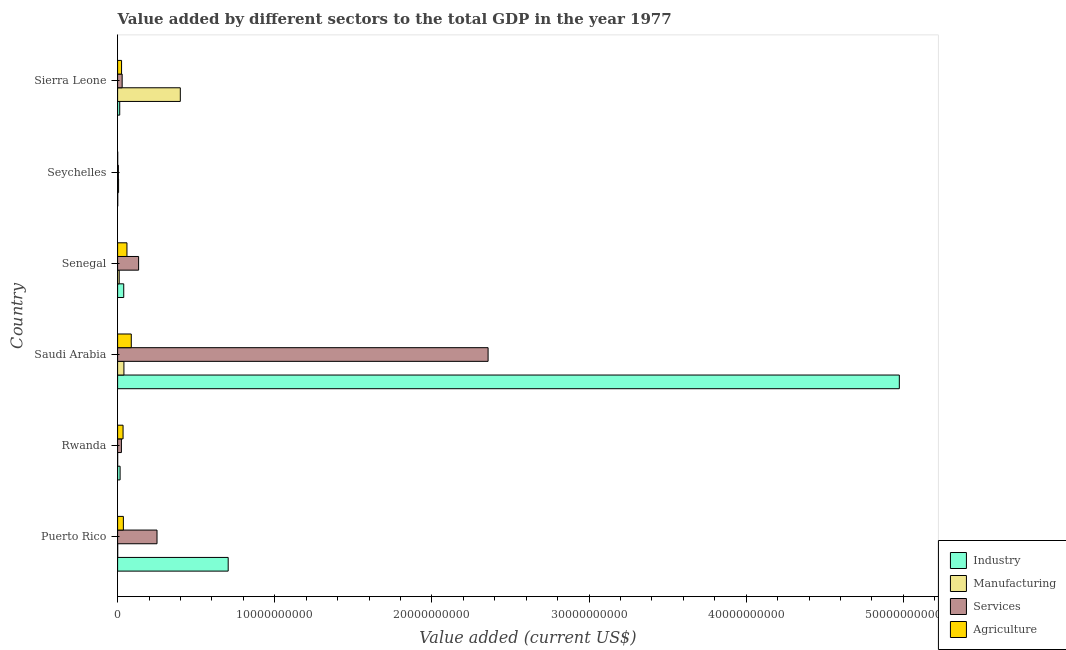How many different coloured bars are there?
Provide a short and direct response. 4. Are the number of bars per tick equal to the number of legend labels?
Provide a succinct answer. Yes. Are the number of bars on each tick of the Y-axis equal?
Offer a very short reply. Yes. How many bars are there on the 5th tick from the bottom?
Offer a very short reply. 4. What is the label of the 5th group of bars from the top?
Make the answer very short. Rwanda. In how many cases, is the number of bars for a given country not equal to the number of legend labels?
Provide a succinct answer. 0. What is the value added by services sector in Rwanda?
Your answer should be compact. 2.41e+08. Across all countries, what is the maximum value added by industrial sector?
Provide a succinct answer. 4.97e+1. Across all countries, what is the minimum value added by industrial sector?
Your answer should be compact. 8.92e+06. In which country was the value added by industrial sector maximum?
Ensure brevity in your answer.  Saudi Arabia. In which country was the value added by services sector minimum?
Your answer should be very brief. Seychelles. What is the total value added by services sector in the graph?
Make the answer very short. 2.80e+1. What is the difference between the value added by manufacturing sector in Rwanda and that in Saudi Arabia?
Offer a very short reply. -3.99e+08. What is the difference between the value added by services sector in Seychelles and the value added by industrial sector in Sierra Leone?
Your response must be concise. -8.48e+07. What is the average value added by manufacturing sector per country?
Offer a terse response. 7.60e+08. What is the difference between the value added by services sector and value added by industrial sector in Puerto Rico?
Your answer should be very brief. -4.53e+09. What is the ratio of the value added by manufacturing sector in Rwanda to that in Seychelles?
Give a very brief answer. 0.04. Is the value added by services sector in Rwanda less than that in Senegal?
Offer a terse response. Yes. Is the difference between the value added by agricultural sector in Saudi Arabia and Senegal greater than the difference between the value added by services sector in Saudi Arabia and Senegal?
Offer a terse response. No. What is the difference between the highest and the second highest value added by industrial sector?
Provide a short and direct response. 4.27e+1. What is the difference between the highest and the lowest value added by services sector?
Provide a succinct answer. 2.35e+1. Is the sum of the value added by agricultural sector in Rwanda and Senegal greater than the maximum value added by manufacturing sector across all countries?
Provide a succinct answer. No. What does the 2nd bar from the top in Seychelles represents?
Provide a short and direct response. Services. What does the 3rd bar from the bottom in Puerto Rico represents?
Your response must be concise. Services. Are all the bars in the graph horizontal?
Ensure brevity in your answer.  Yes. Are the values on the major ticks of X-axis written in scientific E-notation?
Ensure brevity in your answer.  No. How are the legend labels stacked?
Offer a very short reply. Vertical. What is the title of the graph?
Offer a terse response. Value added by different sectors to the total GDP in the year 1977. What is the label or title of the X-axis?
Make the answer very short. Value added (current US$). What is the label or title of the Y-axis?
Give a very brief answer. Country. What is the Value added (current US$) of Industry in Puerto Rico?
Offer a terse response. 7.04e+09. What is the Value added (current US$) in Manufacturing in Puerto Rico?
Provide a short and direct response. 4.63e+06. What is the Value added (current US$) of Services in Puerto Rico?
Your response must be concise. 2.51e+09. What is the Value added (current US$) in Agriculture in Puerto Rico?
Make the answer very short. 3.67e+08. What is the Value added (current US$) of Industry in Rwanda?
Provide a short and direct response. 1.58e+08. What is the Value added (current US$) of Manufacturing in Rwanda?
Ensure brevity in your answer.  2.22e+06. What is the Value added (current US$) of Services in Rwanda?
Give a very brief answer. 2.41e+08. What is the Value added (current US$) of Agriculture in Rwanda?
Offer a terse response. 3.47e+08. What is the Value added (current US$) of Industry in Saudi Arabia?
Provide a succinct answer. 4.97e+1. What is the Value added (current US$) of Manufacturing in Saudi Arabia?
Make the answer very short. 4.01e+08. What is the Value added (current US$) of Services in Saudi Arabia?
Ensure brevity in your answer.  2.36e+1. What is the Value added (current US$) of Agriculture in Saudi Arabia?
Ensure brevity in your answer.  8.70e+08. What is the Value added (current US$) of Industry in Senegal?
Make the answer very short. 3.90e+08. What is the Value added (current US$) in Manufacturing in Senegal?
Give a very brief answer. 1.01e+08. What is the Value added (current US$) in Services in Senegal?
Offer a very short reply. 1.34e+09. What is the Value added (current US$) of Agriculture in Senegal?
Keep it short and to the point. 5.95e+08. What is the Value added (current US$) of Industry in Seychelles?
Give a very brief answer. 8.92e+06. What is the Value added (current US$) in Manufacturing in Seychelles?
Your response must be concise. 6.21e+07. What is the Value added (current US$) of Services in Seychelles?
Provide a succinct answer. 4.97e+07. What is the Value added (current US$) of Agriculture in Seychelles?
Provide a succinct answer. 5.91e+06. What is the Value added (current US$) in Industry in Sierra Leone?
Keep it short and to the point. 1.34e+08. What is the Value added (current US$) in Manufacturing in Sierra Leone?
Make the answer very short. 3.99e+09. What is the Value added (current US$) of Services in Sierra Leone?
Offer a very short reply. 2.90e+08. What is the Value added (current US$) of Agriculture in Sierra Leone?
Your response must be concise. 2.52e+08. Across all countries, what is the maximum Value added (current US$) of Industry?
Give a very brief answer. 4.97e+1. Across all countries, what is the maximum Value added (current US$) of Manufacturing?
Provide a succinct answer. 3.99e+09. Across all countries, what is the maximum Value added (current US$) in Services?
Your answer should be very brief. 2.36e+1. Across all countries, what is the maximum Value added (current US$) of Agriculture?
Your answer should be very brief. 8.70e+08. Across all countries, what is the minimum Value added (current US$) of Industry?
Your response must be concise. 8.92e+06. Across all countries, what is the minimum Value added (current US$) in Manufacturing?
Make the answer very short. 2.22e+06. Across all countries, what is the minimum Value added (current US$) of Services?
Provide a short and direct response. 4.97e+07. Across all countries, what is the minimum Value added (current US$) of Agriculture?
Keep it short and to the point. 5.91e+06. What is the total Value added (current US$) of Industry in the graph?
Provide a succinct answer. 5.75e+1. What is the total Value added (current US$) in Manufacturing in the graph?
Offer a terse response. 4.56e+09. What is the total Value added (current US$) of Services in the graph?
Keep it short and to the point. 2.80e+1. What is the total Value added (current US$) of Agriculture in the graph?
Your answer should be compact. 2.44e+09. What is the difference between the Value added (current US$) of Industry in Puerto Rico and that in Rwanda?
Ensure brevity in your answer.  6.88e+09. What is the difference between the Value added (current US$) in Manufacturing in Puerto Rico and that in Rwanda?
Your response must be concise. 2.41e+06. What is the difference between the Value added (current US$) in Services in Puerto Rico and that in Rwanda?
Make the answer very short. 2.27e+09. What is the difference between the Value added (current US$) in Agriculture in Puerto Rico and that in Rwanda?
Your response must be concise. 2.01e+07. What is the difference between the Value added (current US$) of Industry in Puerto Rico and that in Saudi Arabia?
Ensure brevity in your answer.  -4.27e+1. What is the difference between the Value added (current US$) of Manufacturing in Puerto Rico and that in Saudi Arabia?
Make the answer very short. -3.97e+08. What is the difference between the Value added (current US$) in Services in Puerto Rico and that in Saudi Arabia?
Give a very brief answer. -2.11e+1. What is the difference between the Value added (current US$) of Agriculture in Puerto Rico and that in Saudi Arabia?
Make the answer very short. -5.03e+08. What is the difference between the Value added (current US$) in Industry in Puerto Rico and that in Senegal?
Offer a very short reply. 6.65e+09. What is the difference between the Value added (current US$) of Manufacturing in Puerto Rico and that in Senegal?
Provide a succinct answer. -9.68e+07. What is the difference between the Value added (current US$) in Services in Puerto Rico and that in Senegal?
Make the answer very short. 1.17e+09. What is the difference between the Value added (current US$) of Agriculture in Puerto Rico and that in Senegal?
Provide a succinct answer. -2.28e+08. What is the difference between the Value added (current US$) of Industry in Puerto Rico and that in Seychelles?
Provide a succinct answer. 7.03e+09. What is the difference between the Value added (current US$) in Manufacturing in Puerto Rico and that in Seychelles?
Your answer should be very brief. -5.75e+07. What is the difference between the Value added (current US$) of Services in Puerto Rico and that in Seychelles?
Provide a short and direct response. 2.46e+09. What is the difference between the Value added (current US$) of Agriculture in Puerto Rico and that in Seychelles?
Make the answer very short. 3.61e+08. What is the difference between the Value added (current US$) of Industry in Puerto Rico and that in Sierra Leone?
Offer a very short reply. 6.90e+09. What is the difference between the Value added (current US$) in Manufacturing in Puerto Rico and that in Sierra Leone?
Provide a succinct answer. -3.99e+09. What is the difference between the Value added (current US$) in Services in Puerto Rico and that in Sierra Leone?
Your response must be concise. 2.22e+09. What is the difference between the Value added (current US$) of Agriculture in Puerto Rico and that in Sierra Leone?
Your answer should be very brief. 1.15e+08. What is the difference between the Value added (current US$) of Industry in Rwanda and that in Saudi Arabia?
Your response must be concise. -4.96e+1. What is the difference between the Value added (current US$) in Manufacturing in Rwanda and that in Saudi Arabia?
Offer a terse response. -3.99e+08. What is the difference between the Value added (current US$) of Services in Rwanda and that in Saudi Arabia?
Ensure brevity in your answer.  -2.33e+1. What is the difference between the Value added (current US$) in Agriculture in Rwanda and that in Saudi Arabia?
Your answer should be very brief. -5.23e+08. What is the difference between the Value added (current US$) in Industry in Rwanda and that in Senegal?
Provide a succinct answer. -2.31e+08. What is the difference between the Value added (current US$) in Manufacturing in Rwanda and that in Senegal?
Keep it short and to the point. -9.92e+07. What is the difference between the Value added (current US$) in Services in Rwanda and that in Senegal?
Ensure brevity in your answer.  -1.09e+09. What is the difference between the Value added (current US$) of Agriculture in Rwanda and that in Senegal?
Your answer should be very brief. -2.48e+08. What is the difference between the Value added (current US$) of Industry in Rwanda and that in Seychelles?
Ensure brevity in your answer.  1.49e+08. What is the difference between the Value added (current US$) in Manufacturing in Rwanda and that in Seychelles?
Your response must be concise. -5.99e+07. What is the difference between the Value added (current US$) in Services in Rwanda and that in Seychelles?
Give a very brief answer. 1.92e+08. What is the difference between the Value added (current US$) of Agriculture in Rwanda and that in Seychelles?
Make the answer very short. 3.41e+08. What is the difference between the Value added (current US$) in Industry in Rwanda and that in Sierra Leone?
Your response must be concise. 2.38e+07. What is the difference between the Value added (current US$) in Manufacturing in Rwanda and that in Sierra Leone?
Make the answer very short. -3.99e+09. What is the difference between the Value added (current US$) in Services in Rwanda and that in Sierra Leone?
Your answer should be very brief. -4.84e+07. What is the difference between the Value added (current US$) in Agriculture in Rwanda and that in Sierra Leone?
Provide a succinct answer. 9.52e+07. What is the difference between the Value added (current US$) of Industry in Saudi Arabia and that in Senegal?
Give a very brief answer. 4.94e+1. What is the difference between the Value added (current US$) of Manufacturing in Saudi Arabia and that in Senegal?
Offer a very short reply. 3.00e+08. What is the difference between the Value added (current US$) in Services in Saudi Arabia and that in Senegal?
Your response must be concise. 2.22e+1. What is the difference between the Value added (current US$) of Agriculture in Saudi Arabia and that in Senegal?
Keep it short and to the point. 2.75e+08. What is the difference between the Value added (current US$) of Industry in Saudi Arabia and that in Seychelles?
Provide a succinct answer. 4.97e+1. What is the difference between the Value added (current US$) in Manufacturing in Saudi Arabia and that in Seychelles?
Offer a very short reply. 3.39e+08. What is the difference between the Value added (current US$) in Services in Saudi Arabia and that in Seychelles?
Offer a terse response. 2.35e+1. What is the difference between the Value added (current US$) of Agriculture in Saudi Arabia and that in Seychelles?
Offer a very short reply. 8.64e+08. What is the difference between the Value added (current US$) in Industry in Saudi Arabia and that in Sierra Leone?
Offer a very short reply. 4.96e+1. What is the difference between the Value added (current US$) in Manufacturing in Saudi Arabia and that in Sierra Leone?
Your answer should be very brief. -3.59e+09. What is the difference between the Value added (current US$) in Services in Saudi Arabia and that in Sierra Leone?
Offer a terse response. 2.33e+1. What is the difference between the Value added (current US$) in Agriculture in Saudi Arabia and that in Sierra Leone?
Offer a very short reply. 6.18e+08. What is the difference between the Value added (current US$) of Industry in Senegal and that in Seychelles?
Keep it short and to the point. 3.81e+08. What is the difference between the Value added (current US$) in Manufacturing in Senegal and that in Seychelles?
Make the answer very short. 3.94e+07. What is the difference between the Value added (current US$) in Services in Senegal and that in Seychelles?
Offer a very short reply. 1.29e+09. What is the difference between the Value added (current US$) of Agriculture in Senegal and that in Seychelles?
Offer a very short reply. 5.89e+08. What is the difference between the Value added (current US$) of Industry in Senegal and that in Sierra Leone?
Provide a succinct answer. 2.55e+08. What is the difference between the Value added (current US$) of Manufacturing in Senegal and that in Sierra Leone?
Keep it short and to the point. -3.89e+09. What is the difference between the Value added (current US$) of Services in Senegal and that in Sierra Leone?
Give a very brief answer. 1.05e+09. What is the difference between the Value added (current US$) in Agriculture in Senegal and that in Sierra Leone?
Provide a succinct answer. 3.43e+08. What is the difference between the Value added (current US$) of Industry in Seychelles and that in Sierra Leone?
Your response must be concise. -1.26e+08. What is the difference between the Value added (current US$) in Manufacturing in Seychelles and that in Sierra Leone?
Your response must be concise. -3.93e+09. What is the difference between the Value added (current US$) in Services in Seychelles and that in Sierra Leone?
Make the answer very short. -2.40e+08. What is the difference between the Value added (current US$) in Agriculture in Seychelles and that in Sierra Leone?
Your answer should be compact. -2.46e+08. What is the difference between the Value added (current US$) of Industry in Puerto Rico and the Value added (current US$) of Manufacturing in Rwanda?
Provide a succinct answer. 7.03e+09. What is the difference between the Value added (current US$) of Industry in Puerto Rico and the Value added (current US$) of Services in Rwanda?
Make the answer very short. 6.80e+09. What is the difference between the Value added (current US$) in Industry in Puerto Rico and the Value added (current US$) in Agriculture in Rwanda?
Provide a short and direct response. 6.69e+09. What is the difference between the Value added (current US$) of Manufacturing in Puerto Rico and the Value added (current US$) of Services in Rwanda?
Your answer should be compact. -2.37e+08. What is the difference between the Value added (current US$) in Manufacturing in Puerto Rico and the Value added (current US$) in Agriculture in Rwanda?
Ensure brevity in your answer.  -3.42e+08. What is the difference between the Value added (current US$) of Services in Puerto Rico and the Value added (current US$) of Agriculture in Rwanda?
Offer a terse response. 2.16e+09. What is the difference between the Value added (current US$) of Industry in Puerto Rico and the Value added (current US$) of Manufacturing in Saudi Arabia?
Your response must be concise. 6.64e+09. What is the difference between the Value added (current US$) in Industry in Puerto Rico and the Value added (current US$) in Services in Saudi Arabia?
Provide a succinct answer. -1.65e+1. What is the difference between the Value added (current US$) in Industry in Puerto Rico and the Value added (current US$) in Agriculture in Saudi Arabia?
Your answer should be very brief. 6.17e+09. What is the difference between the Value added (current US$) in Manufacturing in Puerto Rico and the Value added (current US$) in Services in Saudi Arabia?
Offer a very short reply. -2.36e+1. What is the difference between the Value added (current US$) of Manufacturing in Puerto Rico and the Value added (current US$) of Agriculture in Saudi Arabia?
Give a very brief answer. -8.65e+08. What is the difference between the Value added (current US$) of Services in Puerto Rico and the Value added (current US$) of Agriculture in Saudi Arabia?
Your answer should be very brief. 1.64e+09. What is the difference between the Value added (current US$) of Industry in Puerto Rico and the Value added (current US$) of Manufacturing in Senegal?
Provide a short and direct response. 6.94e+09. What is the difference between the Value added (current US$) of Industry in Puerto Rico and the Value added (current US$) of Services in Senegal?
Keep it short and to the point. 5.70e+09. What is the difference between the Value added (current US$) in Industry in Puerto Rico and the Value added (current US$) in Agriculture in Senegal?
Provide a short and direct response. 6.44e+09. What is the difference between the Value added (current US$) in Manufacturing in Puerto Rico and the Value added (current US$) in Services in Senegal?
Ensure brevity in your answer.  -1.33e+09. What is the difference between the Value added (current US$) in Manufacturing in Puerto Rico and the Value added (current US$) in Agriculture in Senegal?
Offer a terse response. -5.90e+08. What is the difference between the Value added (current US$) in Services in Puerto Rico and the Value added (current US$) in Agriculture in Senegal?
Offer a very short reply. 1.91e+09. What is the difference between the Value added (current US$) in Industry in Puerto Rico and the Value added (current US$) in Manufacturing in Seychelles?
Your answer should be compact. 6.97e+09. What is the difference between the Value added (current US$) in Industry in Puerto Rico and the Value added (current US$) in Services in Seychelles?
Keep it short and to the point. 6.99e+09. What is the difference between the Value added (current US$) in Industry in Puerto Rico and the Value added (current US$) in Agriculture in Seychelles?
Give a very brief answer. 7.03e+09. What is the difference between the Value added (current US$) in Manufacturing in Puerto Rico and the Value added (current US$) in Services in Seychelles?
Your answer should be compact. -4.51e+07. What is the difference between the Value added (current US$) in Manufacturing in Puerto Rico and the Value added (current US$) in Agriculture in Seychelles?
Provide a short and direct response. -1.28e+06. What is the difference between the Value added (current US$) of Services in Puerto Rico and the Value added (current US$) of Agriculture in Seychelles?
Make the answer very short. 2.50e+09. What is the difference between the Value added (current US$) of Industry in Puerto Rico and the Value added (current US$) of Manufacturing in Sierra Leone?
Your answer should be compact. 3.05e+09. What is the difference between the Value added (current US$) in Industry in Puerto Rico and the Value added (current US$) in Services in Sierra Leone?
Give a very brief answer. 6.75e+09. What is the difference between the Value added (current US$) of Industry in Puerto Rico and the Value added (current US$) of Agriculture in Sierra Leone?
Give a very brief answer. 6.79e+09. What is the difference between the Value added (current US$) of Manufacturing in Puerto Rico and the Value added (current US$) of Services in Sierra Leone?
Your answer should be very brief. -2.85e+08. What is the difference between the Value added (current US$) of Manufacturing in Puerto Rico and the Value added (current US$) of Agriculture in Sierra Leone?
Make the answer very short. -2.47e+08. What is the difference between the Value added (current US$) of Services in Puerto Rico and the Value added (current US$) of Agriculture in Sierra Leone?
Offer a terse response. 2.26e+09. What is the difference between the Value added (current US$) in Industry in Rwanda and the Value added (current US$) in Manufacturing in Saudi Arabia?
Make the answer very short. -2.43e+08. What is the difference between the Value added (current US$) in Industry in Rwanda and the Value added (current US$) in Services in Saudi Arabia?
Provide a succinct answer. -2.34e+1. What is the difference between the Value added (current US$) in Industry in Rwanda and the Value added (current US$) in Agriculture in Saudi Arabia?
Your answer should be compact. -7.11e+08. What is the difference between the Value added (current US$) in Manufacturing in Rwanda and the Value added (current US$) in Services in Saudi Arabia?
Give a very brief answer. -2.36e+1. What is the difference between the Value added (current US$) in Manufacturing in Rwanda and the Value added (current US$) in Agriculture in Saudi Arabia?
Provide a succinct answer. -8.68e+08. What is the difference between the Value added (current US$) of Services in Rwanda and the Value added (current US$) of Agriculture in Saudi Arabia?
Your answer should be compact. -6.28e+08. What is the difference between the Value added (current US$) of Industry in Rwanda and the Value added (current US$) of Manufacturing in Senegal?
Offer a very short reply. 5.69e+07. What is the difference between the Value added (current US$) of Industry in Rwanda and the Value added (current US$) of Services in Senegal?
Give a very brief answer. -1.18e+09. What is the difference between the Value added (current US$) of Industry in Rwanda and the Value added (current US$) of Agriculture in Senegal?
Provide a short and direct response. -4.37e+08. What is the difference between the Value added (current US$) in Manufacturing in Rwanda and the Value added (current US$) in Services in Senegal?
Your answer should be very brief. -1.33e+09. What is the difference between the Value added (current US$) in Manufacturing in Rwanda and the Value added (current US$) in Agriculture in Senegal?
Your response must be concise. -5.93e+08. What is the difference between the Value added (current US$) in Services in Rwanda and the Value added (current US$) in Agriculture in Senegal?
Ensure brevity in your answer.  -3.54e+08. What is the difference between the Value added (current US$) of Industry in Rwanda and the Value added (current US$) of Manufacturing in Seychelles?
Keep it short and to the point. 9.62e+07. What is the difference between the Value added (current US$) in Industry in Rwanda and the Value added (current US$) in Services in Seychelles?
Your response must be concise. 1.09e+08. What is the difference between the Value added (current US$) of Industry in Rwanda and the Value added (current US$) of Agriculture in Seychelles?
Ensure brevity in your answer.  1.52e+08. What is the difference between the Value added (current US$) in Manufacturing in Rwanda and the Value added (current US$) in Services in Seychelles?
Offer a very short reply. -4.75e+07. What is the difference between the Value added (current US$) of Manufacturing in Rwanda and the Value added (current US$) of Agriculture in Seychelles?
Your answer should be compact. -3.69e+06. What is the difference between the Value added (current US$) in Services in Rwanda and the Value added (current US$) in Agriculture in Seychelles?
Keep it short and to the point. 2.35e+08. What is the difference between the Value added (current US$) in Industry in Rwanda and the Value added (current US$) in Manufacturing in Sierra Leone?
Keep it short and to the point. -3.83e+09. What is the difference between the Value added (current US$) in Industry in Rwanda and the Value added (current US$) in Services in Sierra Leone?
Your answer should be compact. -1.31e+08. What is the difference between the Value added (current US$) of Industry in Rwanda and the Value added (current US$) of Agriculture in Sierra Leone?
Give a very brief answer. -9.33e+07. What is the difference between the Value added (current US$) of Manufacturing in Rwanda and the Value added (current US$) of Services in Sierra Leone?
Provide a short and direct response. -2.88e+08. What is the difference between the Value added (current US$) in Manufacturing in Rwanda and the Value added (current US$) in Agriculture in Sierra Leone?
Offer a very short reply. -2.49e+08. What is the difference between the Value added (current US$) in Services in Rwanda and the Value added (current US$) in Agriculture in Sierra Leone?
Keep it short and to the point. -1.03e+07. What is the difference between the Value added (current US$) of Industry in Saudi Arabia and the Value added (current US$) of Manufacturing in Senegal?
Provide a short and direct response. 4.96e+1. What is the difference between the Value added (current US$) of Industry in Saudi Arabia and the Value added (current US$) of Services in Senegal?
Provide a succinct answer. 4.84e+1. What is the difference between the Value added (current US$) of Industry in Saudi Arabia and the Value added (current US$) of Agriculture in Senegal?
Your response must be concise. 4.91e+1. What is the difference between the Value added (current US$) in Manufacturing in Saudi Arabia and the Value added (current US$) in Services in Senegal?
Provide a short and direct response. -9.35e+08. What is the difference between the Value added (current US$) in Manufacturing in Saudi Arabia and the Value added (current US$) in Agriculture in Senegal?
Keep it short and to the point. -1.93e+08. What is the difference between the Value added (current US$) in Services in Saudi Arabia and the Value added (current US$) in Agriculture in Senegal?
Your response must be concise. 2.30e+1. What is the difference between the Value added (current US$) of Industry in Saudi Arabia and the Value added (current US$) of Manufacturing in Seychelles?
Ensure brevity in your answer.  4.97e+1. What is the difference between the Value added (current US$) of Industry in Saudi Arabia and the Value added (current US$) of Services in Seychelles?
Provide a short and direct response. 4.97e+1. What is the difference between the Value added (current US$) in Industry in Saudi Arabia and the Value added (current US$) in Agriculture in Seychelles?
Your response must be concise. 4.97e+1. What is the difference between the Value added (current US$) in Manufacturing in Saudi Arabia and the Value added (current US$) in Services in Seychelles?
Your answer should be very brief. 3.52e+08. What is the difference between the Value added (current US$) in Manufacturing in Saudi Arabia and the Value added (current US$) in Agriculture in Seychelles?
Offer a terse response. 3.96e+08. What is the difference between the Value added (current US$) in Services in Saudi Arabia and the Value added (current US$) in Agriculture in Seychelles?
Provide a short and direct response. 2.36e+1. What is the difference between the Value added (current US$) in Industry in Saudi Arabia and the Value added (current US$) in Manufacturing in Sierra Leone?
Give a very brief answer. 4.58e+1. What is the difference between the Value added (current US$) in Industry in Saudi Arabia and the Value added (current US$) in Services in Sierra Leone?
Ensure brevity in your answer.  4.95e+1. What is the difference between the Value added (current US$) of Industry in Saudi Arabia and the Value added (current US$) of Agriculture in Sierra Leone?
Ensure brevity in your answer.  4.95e+1. What is the difference between the Value added (current US$) in Manufacturing in Saudi Arabia and the Value added (current US$) in Services in Sierra Leone?
Your answer should be compact. 1.12e+08. What is the difference between the Value added (current US$) in Manufacturing in Saudi Arabia and the Value added (current US$) in Agriculture in Sierra Leone?
Your answer should be compact. 1.50e+08. What is the difference between the Value added (current US$) in Services in Saudi Arabia and the Value added (current US$) in Agriculture in Sierra Leone?
Give a very brief answer. 2.33e+1. What is the difference between the Value added (current US$) in Industry in Senegal and the Value added (current US$) in Manufacturing in Seychelles?
Your answer should be compact. 3.28e+08. What is the difference between the Value added (current US$) in Industry in Senegal and the Value added (current US$) in Services in Seychelles?
Make the answer very short. 3.40e+08. What is the difference between the Value added (current US$) of Industry in Senegal and the Value added (current US$) of Agriculture in Seychelles?
Provide a short and direct response. 3.84e+08. What is the difference between the Value added (current US$) in Manufacturing in Senegal and the Value added (current US$) in Services in Seychelles?
Offer a very short reply. 5.18e+07. What is the difference between the Value added (current US$) of Manufacturing in Senegal and the Value added (current US$) of Agriculture in Seychelles?
Your answer should be very brief. 9.55e+07. What is the difference between the Value added (current US$) of Services in Senegal and the Value added (current US$) of Agriculture in Seychelles?
Your response must be concise. 1.33e+09. What is the difference between the Value added (current US$) of Industry in Senegal and the Value added (current US$) of Manufacturing in Sierra Leone?
Your answer should be very brief. -3.60e+09. What is the difference between the Value added (current US$) of Industry in Senegal and the Value added (current US$) of Services in Sierra Leone?
Ensure brevity in your answer.  9.99e+07. What is the difference between the Value added (current US$) in Industry in Senegal and the Value added (current US$) in Agriculture in Sierra Leone?
Make the answer very short. 1.38e+08. What is the difference between the Value added (current US$) in Manufacturing in Senegal and the Value added (current US$) in Services in Sierra Leone?
Make the answer very short. -1.88e+08. What is the difference between the Value added (current US$) of Manufacturing in Senegal and the Value added (current US$) of Agriculture in Sierra Leone?
Your response must be concise. -1.50e+08. What is the difference between the Value added (current US$) of Services in Senegal and the Value added (current US$) of Agriculture in Sierra Leone?
Ensure brevity in your answer.  1.08e+09. What is the difference between the Value added (current US$) in Industry in Seychelles and the Value added (current US$) in Manufacturing in Sierra Leone?
Offer a very short reply. -3.98e+09. What is the difference between the Value added (current US$) of Industry in Seychelles and the Value added (current US$) of Services in Sierra Leone?
Ensure brevity in your answer.  -2.81e+08. What is the difference between the Value added (current US$) of Industry in Seychelles and the Value added (current US$) of Agriculture in Sierra Leone?
Your response must be concise. -2.43e+08. What is the difference between the Value added (current US$) in Manufacturing in Seychelles and the Value added (current US$) in Services in Sierra Leone?
Offer a very short reply. -2.28e+08. What is the difference between the Value added (current US$) in Manufacturing in Seychelles and the Value added (current US$) in Agriculture in Sierra Leone?
Your answer should be very brief. -1.90e+08. What is the difference between the Value added (current US$) in Services in Seychelles and the Value added (current US$) in Agriculture in Sierra Leone?
Your answer should be very brief. -2.02e+08. What is the average Value added (current US$) in Industry per country?
Provide a succinct answer. 9.58e+09. What is the average Value added (current US$) in Manufacturing per country?
Make the answer very short. 7.60e+08. What is the average Value added (current US$) in Services per country?
Your response must be concise. 4.67e+09. What is the average Value added (current US$) of Agriculture per country?
Your answer should be very brief. 4.06e+08. What is the difference between the Value added (current US$) in Industry and Value added (current US$) in Manufacturing in Puerto Rico?
Your answer should be very brief. 7.03e+09. What is the difference between the Value added (current US$) in Industry and Value added (current US$) in Services in Puerto Rico?
Ensure brevity in your answer.  4.53e+09. What is the difference between the Value added (current US$) in Industry and Value added (current US$) in Agriculture in Puerto Rico?
Provide a short and direct response. 6.67e+09. What is the difference between the Value added (current US$) of Manufacturing and Value added (current US$) of Services in Puerto Rico?
Keep it short and to the point. -2.50e+09. What is the difference between the Value added (current US$) of Manufacturing and Value added (current US$) of Agriculture in Puerto Rico?
Ensure brevity in your answer.  -3.62e+08. What is the difference between the Value added (current US$) of Services and Value added (current US$) of Agriculture in Puerto Rico?
Your answer should be compact. 2.14e+09. What is the difference between the Value added (current US$) in Industry and Value added (current US$) in Manufacturing in Rwanda?
Keep it short and to the point. 1.56e+08. What is the difference between the Value added (current US$) in Industry and Value added (current US$) in Services in Rwanda?
Offer a terse response. -8.31e+07. What is the difference between the Value added (current US$) of Industry and Value added (current US$) of Agriculture in Rwanda?
Ensure brevity in your answer.  -1.89e+08. What is the difference between the Value added (current US$) of Manufacturing and Value added (current US$) of Services in Rwanda?
Keep it short and to the point. -2.39e+08. What is the difference between the Value added (current US$) in Manufacturing and Value added (current US$) in Agriculture in Rwanda?
Offer a terse response. -3.45e+08. What is the difference between the Value added (current US$) of Services and Value added (current US$) of Agriculture in Rwanda?
Provide a short and direct response. -1.05e+08. What is the difference between the Value added (current US$) in Industry and Value added (current US$) in Manufacturing in Saudi Arabia?
Your answer should be very brief. 4.93e+1. What is the difference between the Value added (current US$) of Industry and Value added (current US$) of Services in Saudi Arabia?
Your answer should be very brief. 2.62e+1. What is the difference between the Value added (current US$) in Industry and Value added (current US$) in Agriculture in Saudi Arabia?
Provide a succinct answer. 4.89e+1. What is the difference between the Value added (current US$) in Manufacturing and Value added (current US$) in Services in Saudi Arabia?
Provide a succinct answer. -2.32e+1. What is the difference between the Value added (current US$) of Manufacturing and Value added (current US$) of Agriculture in Saudi Arabia?
Offer a very short reply. -4.68e+08. What is the difference between the Value added (current US$) in Services and Value added (current US$) in Agriculture in Saudi Arabia?
Give a very brief answer. 2.27e+1. What is the difference between the Value added (current US$) of Industry and Value added (current US$) of Manufacturing in Senegal?
Offer a terse response. 2.88e+08. What is the difference between the Value added (current US$) in Industry and Value added (current US$) in Services in Senegal?
Offer a very short reply. -9.46e+08. What is the difference between the Value added (current US$) of Industry and Value added (current US$) of Agriculture in Senegal?
Make the answer very short. -2.05e+08. What is the difference between the Value added (current US$) in Manufacturing and Value added (current US$) in Services in Senegal?
Your response must be concise. -1.23e+09. What is the difference between the Value added (current US$) in Manufacturing and Value added (current US$) in Agriculture in Senegal?
Your answer should be very brief. -4.94e+08. What is the difference between the Value added (current US$) in Services and Value added (current US$) in Agriculture in Senegal?
Your answer should be very brief. 7.41e+08. What is the difference between the Value added (current US$) of Industry and Value added (current US$) of Manufacturing in Seychelles?
Make the answer very short. -5.32e+07. What is the difference between the Value added (current US$) of Industry and Value added (current US$) of Services in Seychelles?
Your answer should be very brief. -4.08e+07. What is the difference between the Value added (current US$) in Industry and Value added (current US$) in Agriculture in Seychelles?
Offer a very short reply. 3.01e+06. What is the difference between the Value added (current US$) in Manufacturing and Value added (current US$) in Services in Seychelles?
Offer a terse response. 1.24e+07. What is the difference between the Value added (current US$) in Manufacturing and Value added (current US$) in Agriculture in Seychelles?
Provide a succinct answer. 5.62e+07. What is the difference between the Value added (current US$) of Services and Value added (current US$) of Agriculture in Seychelles?
Your answer should be compact. 4.38e+07. What is the difference between the Value added (current US$) of Industry and Value added (current US$) of Manufacturing in Sierra Leone?
Ensure brevity in your answer.  -3.86e+09. What is the difference between the Value added (current US$) in Industry and Value added (current US$) in Services in Sierra Leone?
Keep it short and to the point. -1.55e+08. What is the difference between the Value added (current US$) of Industry and Value added (current US$) of Agriculture in Sierra Leone?
Your answer should be compact. -1.17e+08. What is the difference between the Value added (current US$) in Manufacturing and Value added (current US$) in Services in Sierra Leone?
Provide a short and direct response. 3.70e+09. What is the difference between the Value added (current US$) of Manufacturing and Value added (current US$) of Agriculture in Sierra Leone?
Ensure brevity in your answer.  3.74e+09. What is the difference between the Value added (current US$) of Services and Value added (current US$) of Agriculture in Sierra Leone?
Your response must be concise. 3.81e+07. What is the ratio of the Value added (current US$) of Industry in Puerto Rico to that in Rwanda?
Offer a terse response. 44.44. What is the ratio of the Value added (current US$) of Manufacturing in Puerto Rico to that in Rwanda?
Your answer should be very brief. 2.08. What is the ratio of the Value added (current US$) in Services in Puerto Rico to that in Rwanda?
Your answer should be very brief. 10.39. What is the ratio of the Value added (current US$) in Agriculture in Puerto Rico to that in Rwanda?
Offer a terse response. 1.06. What is the ratio of the Value added (current US$) in Industry in Puerto Rico to that in Saudi Arabia?
Provide a short and direct response. 0.14. What is the ratio of the Value added (current US$) in Manufacturing in Puerto Rico to that in Saudi Arabia?
Your response must be concise. 0.01. What is the ratio of the Value added (current US$) of Services in Puerto Rico to that in Saudi Arabia?
Offer a terse response. 0.11. What is the ratio of the Value added (current US$) of Agriculture in Puerto Rico to that in Saudi Arabia?
Keep it short and to the point. 0.42. What is the ratio of the Value added (current US$) of Industry in Puerto Rico to that in Senegal?
Give a very brief answer. 18.06. What is the ratio of the Value added (current US$) of Manufacturing in Puerto Rico to that in Senegal?
Offer a terse response. 0.05. What is the ratio of the Value added (current US$) of Services in Puerto Rico to that in Senegal?
Provide a succinct answer. 1.88. What is the ratio of the Value added (current US$) in Agriculture in Puerto Rico to that in Senegal?
Offer a very short reply. 0.62. What is the ratio of the Value added (current US$) in Industry in Puerto Rico to that in Seychelles?
Offer a very short reply. 788.64. What is the ratio of the Value added (current US$) of Manufacturing in Puerto Rico to that in Seychelles?
Keep it short and to the point. 0.07. What is the ratio of the Value added (current US$) of Services in Puerto Rico to that in Seychelles?
Make the answer very short. 50.46. What is the ratio of the Value added (current US$) in Agriculture in Puerto Rico to that in Seychelles?
Offer a very short reply. 62.05. What is the ratio of the Value added (current US$) in Industry in Puerto Rico to that in Sierra Leone?
Provide a succinct answer. 52.32. What is the ratio of the Value added (current US$) in Manufacturing in Puerto Rico to that in Sierra Leone?
Offer a very short reply. 0. What is the ratio of the Value added (current US$) in Services in Puerto Rico to that in Sierra Leone?
Keep it short and to the point. 8.65. What is the ratio of the Value added (current US$) of Agriculture in Puerto Rico to that in Sierra Leone?
Your answer should be compact. 1.46. What is the ratio of the Value added (current US$) of Industry in Rwanda to that in Saudi Arabia?
Your answer should be very brief. 0. What is the ratio of the Value added (current US$) in Manufacturing in Rwanda to that in Saudi Arabia?
Keep it short and to the point. 0.01. What is the ratio of the Value added (current US$) of Services in Rwanda to that in Saudi Arabia?
Your answer should be very brief. 0.01. What is the ratio of the Value added (current US$) in Agriculture in Rwanda to that in Saudi Arabia?
Your answer should be compact. 0.4. What is the ratio of the Value added (current US$) in Industry in Rwanda to that in Senegal?
Give a very brief answer. 0.41. What is the ratio of the Value added (current US$) of Manufacturing in Rwanda to that in Senegal?
Ensure brevity in your answer.  0.02. What is the ratio of the Value added (current US$) of Services in Rwanda to that in Senegal?
Your answer should be very brief. 0.18. What is the ratio of the Value added (current US$) of Agriculture in Rwanda to that in Senegal?
Offer a terse response. 0.58. What is the ratio of the Value added (current US$) in Industry in Rwanda to that in Seychelles?
Your answer should be very brief. 17.75. What is the ratio of the Value added (current US$) in Manufacturing in Rwanda to that in Seychelles?
Provide a short and direct response. 0.04. What is the ratio of the Value added (current US$) of Services in Rwanda to that in Seychelles?
Offer a terse response. 4.86. What is the ratio of the Value added (current US$) in Agriculture in Rwanda to that in Seychelles?
Offer a very short reply. 58.66. What is the ratio of the Value added (current US$) in Industry in Rwanda to that in Sierra Leone?
Provide a succinct answer. 1.18. What is the ratio of the Value added (current US$) in Manufacturing in Rwanda to that in Sierra Leone?
Your answer should be compact. 0. What is the ratio of the Value added (current US$) of Services in Rwanda to that in Sierra Leone?
Offer a very short reply. 0.83. What is the ratio of the Value added (current US$) in Agriculture in Rwanda to that in Sierra Leone?
Your answer should be compact. 1.38. What is the ratio of the Value added (current US$) in Industry in Saudi Arabia to that in Senegal?
Provide a succinct answer. 127.65. What is the ratio of the Value added (current US$) of Manufacturing in Saudi Arabia to that in Senegal?
Give a very brief answer. 3.96. What is the ratio of the Value added (current US$) of Services in Saudi Arabia to that in Senegal?
Your answer should be very brief. 17.64. What is the ratio of the Value added (current US$) of Agriculture in Saudi Arabia to that in Senegal?
Keep it short and to the point. 1.46. What is the ratio of the Value added (current US$) in Industry in Saudi Arabia to that in Seychelles?
Your response must be concise. 5574.85. What is the ratio of the Value added (current US$) in Manufacturing in Saudi Arabia to that in Seychelles?
Keep it short and to the point. 6.47. What is the ratio of the Value added (current US$) in Services in Saudi Arabia to that in Seychelles?
Provide a succinct answer. 474.45. What is the ratio of the Value added (current US$) in Agriculture in Saudi Arabia to that in Seychelles?
Offer a terse response. 147.08. What is the ratio of the Value added (current US$) of Industry in Saudi Arabia to that in Sierra Leone?
Your response must be concise. 369.85. What is the ratio of the Value added (current US$) of Manufacturing in Saudi Arabia to that in Sierra Leone?
Ensure brevity in your answer.  0.1. What is the ratio of the Value added (current US$) in Services in Saudi Arabia to that in Sierra Leone?
Ensure brevity in your answer.  81.35. What is the ratio of the Value added (current US$) of Agriculture in Saudi Arabia to that in Sierra Leone?
Your response must be concise. 3.46. What is the ratio of the Value added (current US$) of Industry in Senegal to that in Seychelles?
Give a very brief answer. 43.67. What is the ratio of the Value added (current US$) in Manufacturing in Senegal to that in Seychelles?
Provide a succinct answer. 1.63. What is the ratio of the Value added (current US$) in Services in Senegal to that in Seychelles?
Offer a very short reply. 26.89. What is the ratio of the Value added (current US$) in Agriculture in Senegal to that in Seychelles?
Provide a short and direct response. 100.61. What is the ratio of the Value added (current US$) in Industry in Senegal to that in Sierra Leone?
Make the answer very short. 2.9. What is the ratio of the Value added (current US$) of Manufacturing in Senegal to that in Sierra Leone?
Provide a short and direct response. 0.03. What is the ratio of the Value added (current US$) in Services in Senegal to that in Sierra Leone?
Your answer should be compact. 4.61. What is the ratio of the Value added (current US$) in Agriculture in Senegal to that in Sierra Leone?
Provide a succinct answer. 2.36. What is the ratio of the Value added (current US$) of Industry in Seychelles to that in Sierra Leone?
Give a very brief answer. 0.07. What is the ratio of the Value added (current US$) of Manufacturing in Seychelles to that in Sierra Leone?
Offer a terse response. 0.02. What is the ratio of the Value added (current US$) in Services in Seychelles to that in Sierra Leone?
Keep it short and to the point. 0.17. What is the ratio of the Value added (current US$) of Agriculture in Seychelles to that in Sierra Leone?
Ensure brevity in your answer.  0.02. What is the difference between the highest and the second highest Value added (current US$) of Industry?
Offer a terse response. 4.27e+1. What is the difference between the highest and the second highest Value added (current US$) in Manufacturing?
Your response must be concise. 3.59e+09. What is the difference between the highest and the second highest Value added (current US$) of Services?
Your answer should be very brief. 2.11e+1. What is the difference between the highest and the second highest Value added (current US$) in Agriculture?
Offer a terse response. 2.75e+08. What is the difference between the highest and the lowest Value added (current US$) of Industry?
Give a very brief answer. 4.97e+1. What is the difference between the highest and the lowest Value added (current US$) of Manufacturing?
Your answer should be very brief. 3.99e+09. What is the difference between the highest and the lowest Value added (current US$) in Services?
Offer a very short reply. 2.35e+1. What is the difference between the highest and the lowest Value added (current US$) in Agriculture?
Keep it short and to the point. 8.64e+08. 